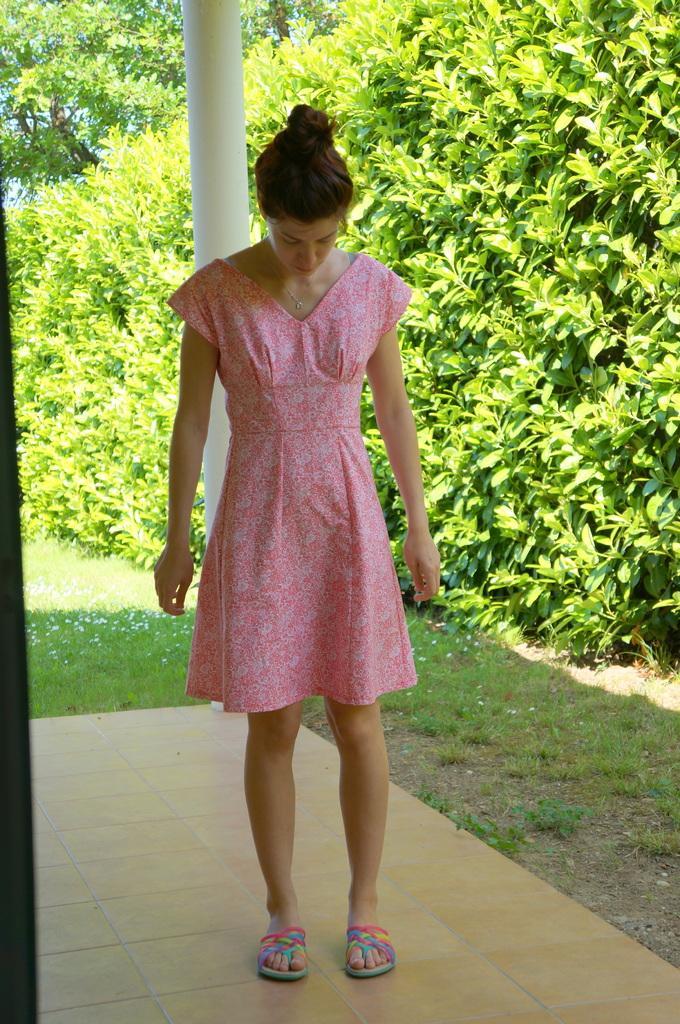Describe this image in one or two sentences. Here I can see a woman standing and looking at the downwards. In the background there are trees, plants and grass on the ground. At the back of this woman there is a pole. 